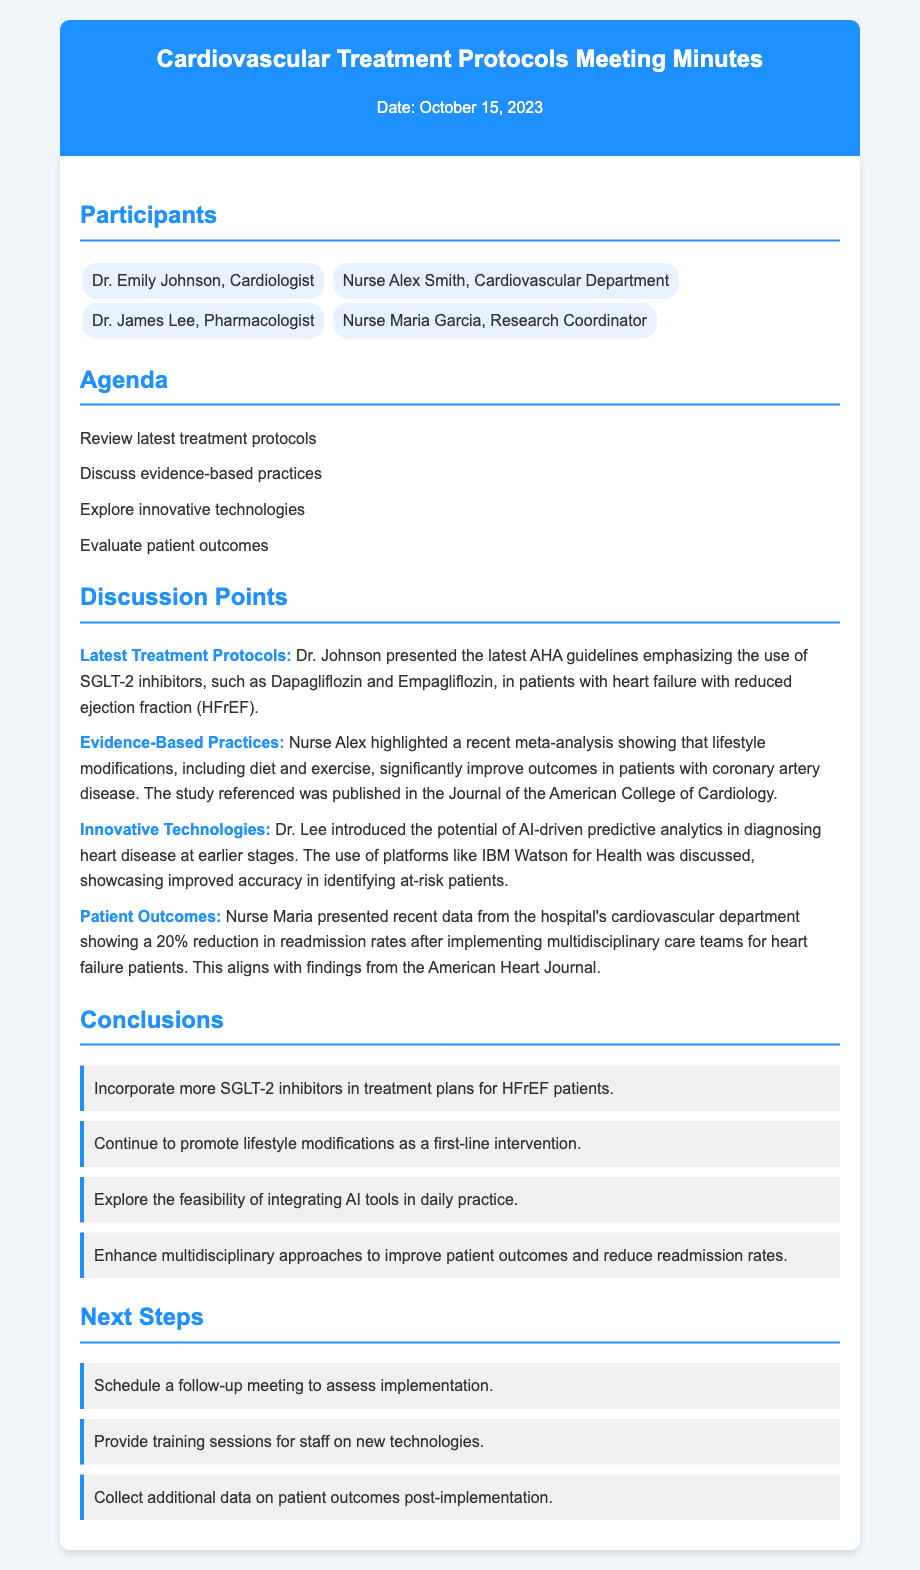What is the date of the meeting? The date of the meeting is clearly stated at the top of the document.
Answer: October 15, 2023 Who presented the latest treatment protocols? Dr. Johnson is mentioned as the presenter of the latest treatment protocols in the document.
Answer: Dr. Emily Johnson What is one of the medications emphasized for HFrEF patients? The document specifically mentions SGLT-2 inhibitors and provides examples of medications.
Answer: Dapagliflozin What reduction in readmission rates was reported? Nurse Maria presented data showing a specific percentage reduction in readmission rates in the discussion points.
Answer: 20% What is one innovative technology discussed? The document mentions the use of AI-driven predictive analytics as a topic of discussion.
Answer: AI-driven predictive analytics Why should lifestyle modifications be promoted? A recent meta-analysis showing benefits is highlighted as evidence in the document.
Answer: To improve outcomes What is one next step mentioned in the document? The document lists specific actions to be taken after the meeting under "Next Steps."
Answer: Schedule a follow-up meeting Who highlighted the recent meta-analysis on lifestyle modifications? The participant who brought up the meta-analysis is specifically named in the document.
Answer: Nurse Alex Smith 